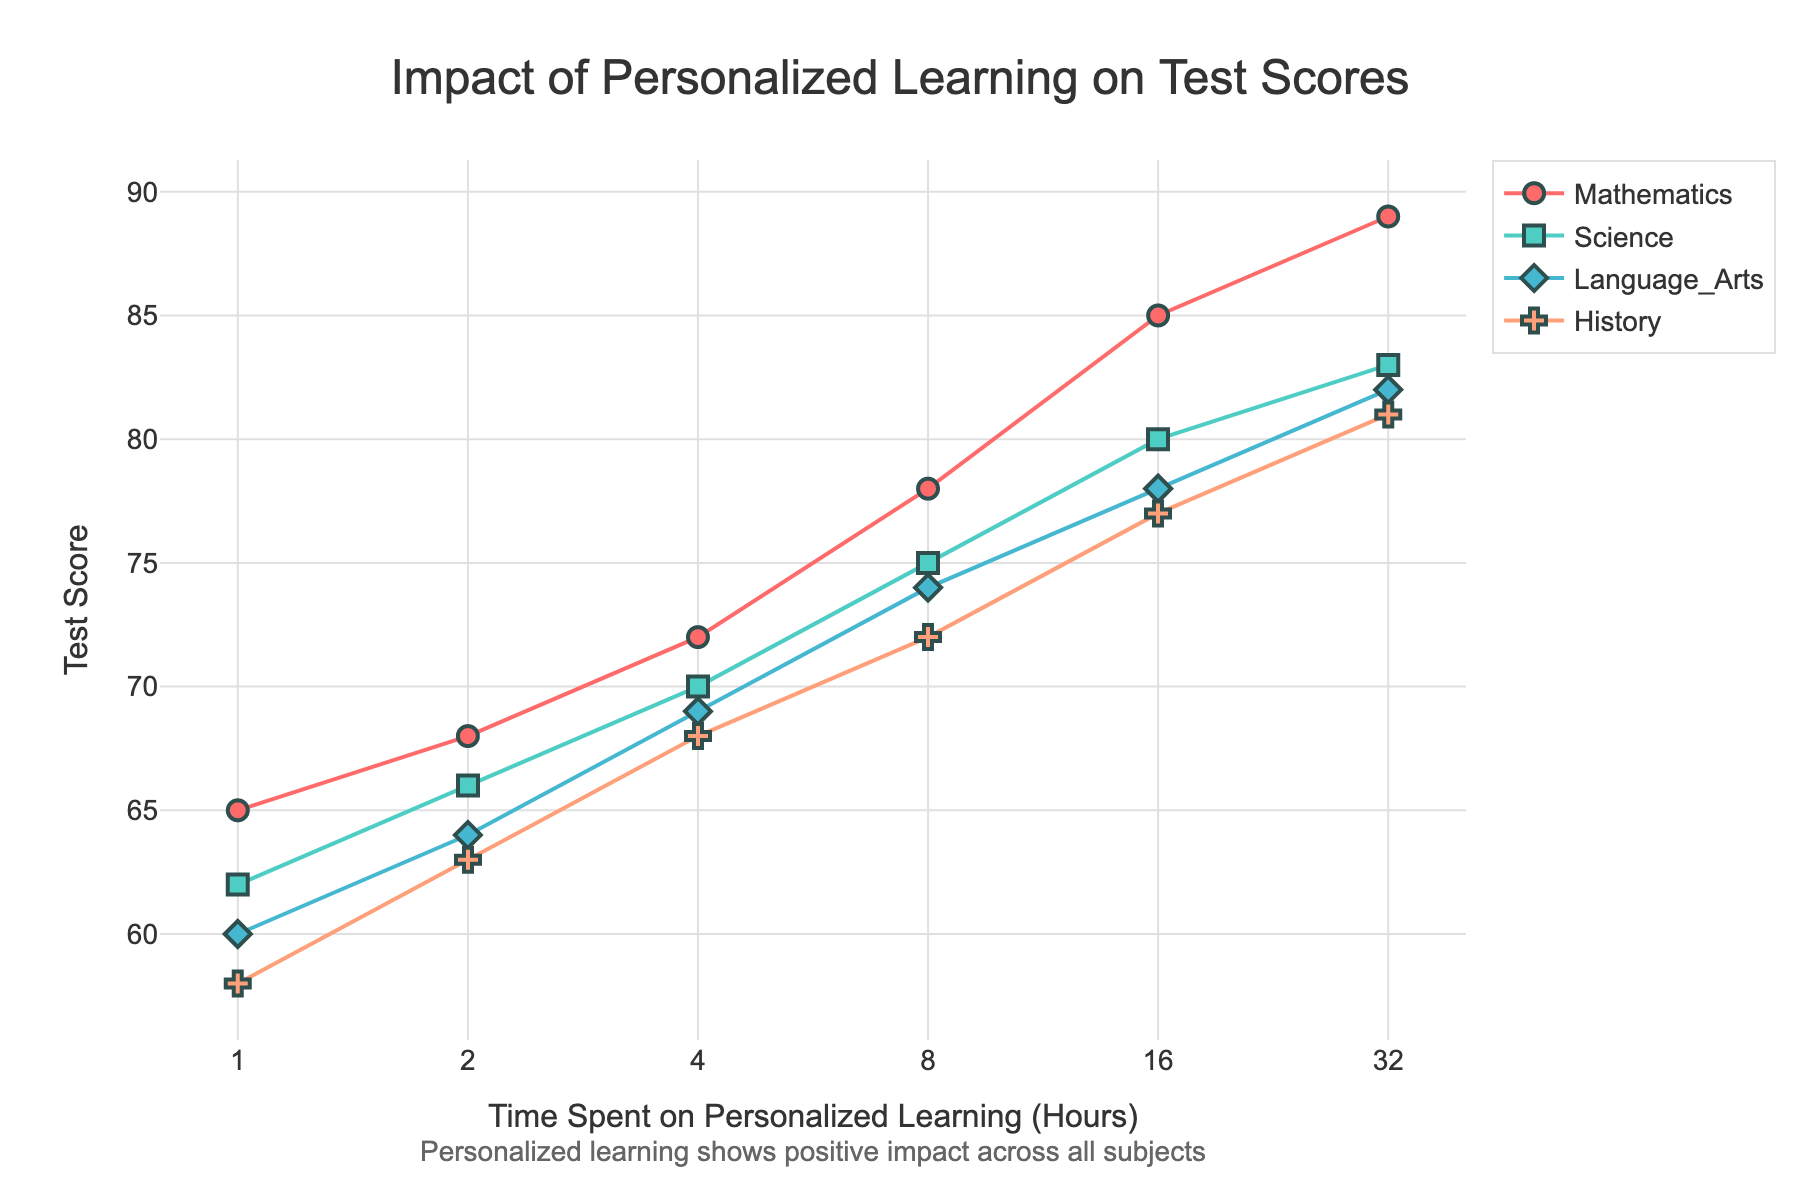What is the title of the scatter plot? The title is displayed at the top center of the plot. It reads "Impact of Personalized Learning on Test Scores."
Answer: Impact of Personalized Learning on Test Scores How much time did it take for the Mathematics test score to reach 85? On the x-axis with the log scale, look up the point on the Mathematics line where the y-axis (Test Score) reaches 85. The corresponding x-axis (Time Spent Hours) value is 16 hours.
Answer: 16 hours Which subject shows the highest test score at 32 hours of personalized learning? On the line chart, trace the points corresponding to 32 hours for each subject and identify the highest y-axis value. Mathematics shows the highest test score at about 89.
Answer: Mathematics What are the subjects displayed in the plot? Refer to the legend in the plot which lists all the subject names displayed. The subjects are Mathematics, Science, Language Arts, and History.
Answer: Mathematics, Science, Language Arts, History How does the test score trend for Science compare to Mathematics as time spent on personalized learning increases? Observe the lines representing Science and Mathematics. Both show increasing trends, but Mathematics test scores tend to be slightly higher than Science scores for the same amount of time spent on personalized learning.
Answer: Mathematics scores are generally higher What is the test score for Language Arts at 4 hours of personalized learning? Follow the Language Arts line to the point where the x-axis (Time Spent Hours) is 4. The corresponding y-axis (Test Score) is approximately 69.
Answer: 69 Between which two subjects is the difference in test scores the smallest at 8 hours of personalized learning? Compare the test scores at 8 hours for all subjects. Science shows a score of 75, and Language Arts shows a score of 74. The difference is 1, which is the smallest among the comparisons.
Answer: Science and Language Arts If we double the time spent on personalized learning from 4 to 8 hours, how much does the test score for History increase? Look at the test scores for History at 4 hours and 8 hours. Subtract the score at 4 hours (68) from the score at 8 hours (72). The increase is 72 - 68 = 4.
Answer: 4 points At what time spent do all subjects start to show a noticeable positive impact on test scores? Review the trend for each subject to see when a noticeable increase in slope begins. Generally, all subjects show a noticeable upward trend starting around 4 hours.
Answer: Around 4 hours Which subject has the least overall improvement in test scores from 1 hour to 32 hours? Calculate the difference in test scores for each subject from 1 hour to 32 hours. History goes from 58 to 81, a difference of 23, which is the smallest.
Answer: History 